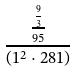Convert formula to latex. <formula><loc_0><loc_0><loc_500><loc_500>\frac { \frac { \frac { 9 } { 3 } } { 9 5 } } { ( 1 ^ { 2 } \cdot 2 8 1 ) }</formula> 